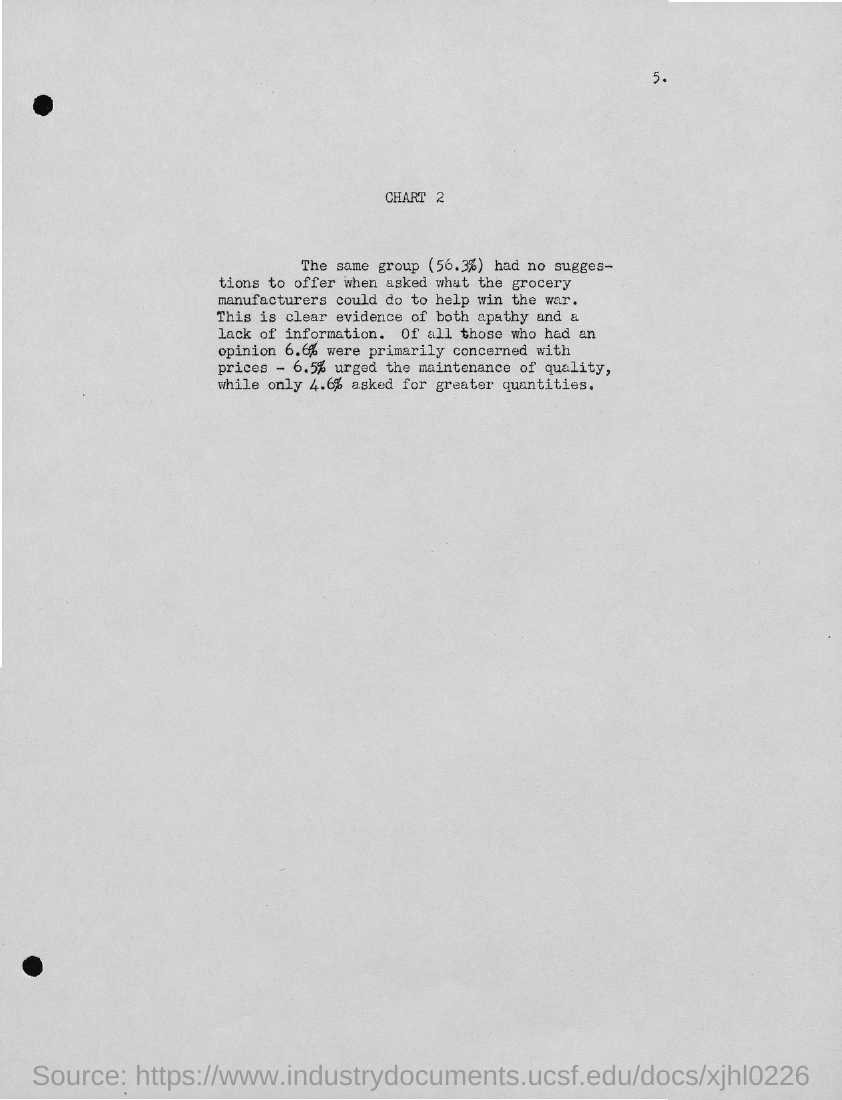Point out several critical features in this image. This is the chart number 2. I, [insert name], am declaring that the page number is 5. 